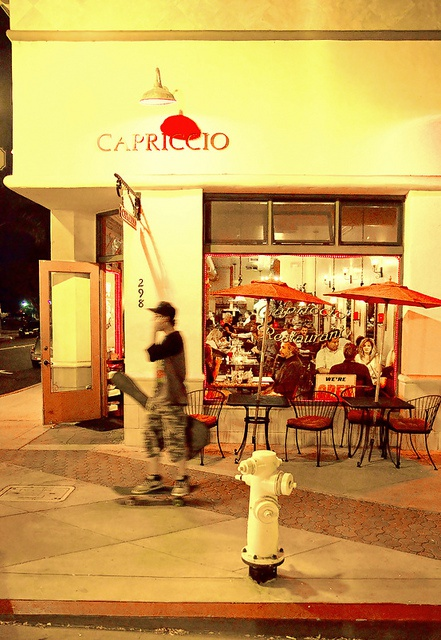Describe the objects in this image and their specific colors. I can see people in orange, maroon, olive, and black tones, fire hydrant in orange, khaki, and brown tones, umbrella in orange, red, and brown tones, chair in orange, maroon, black, and brown tones, and umbrella in orange, red, and brown tones in this image. 